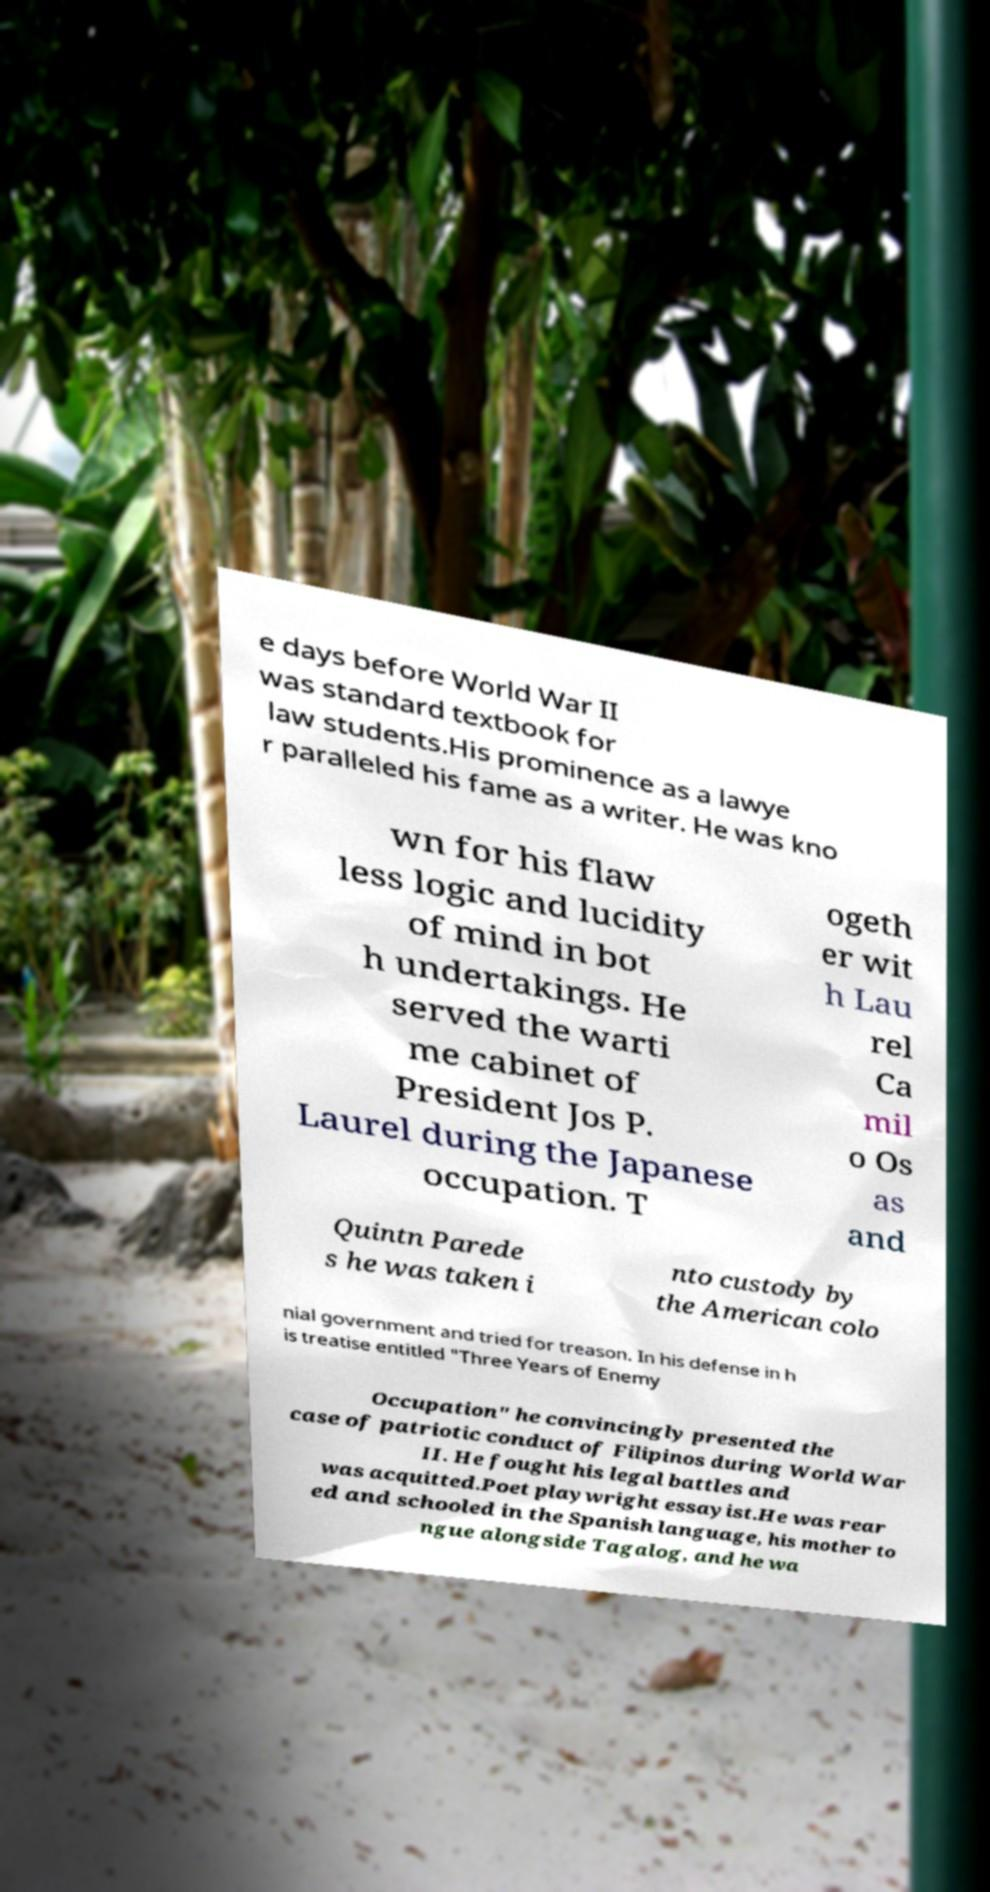Please read and relay the text visible in this image. What does it say? e days before World War II was standard textbook for law students.His prominence as a lawye r paralleled his fame as a writer. He was kno wn for his flaw less logic and lucidity of mind in bot h undertakings. He served the warti me cabinet of President Jos P. Laurel during the Japanese occupation. T ogeth er wit h Lau rel Ca mil o Os as and Quintn Parede s he was taken i nto custody by the American colo nial government and tried for treason. In his defense in h is treatise entitled "Three Years of Enemy Occupation" he convincingly presented the case of patriotic conduct of Filipinos during World War II. He fought his legal battles and was acquitted.Poet playwright essayist.He was rear ed and schooled in the Spanish language, his mother to ngue alongside Tagalog, and he wa 